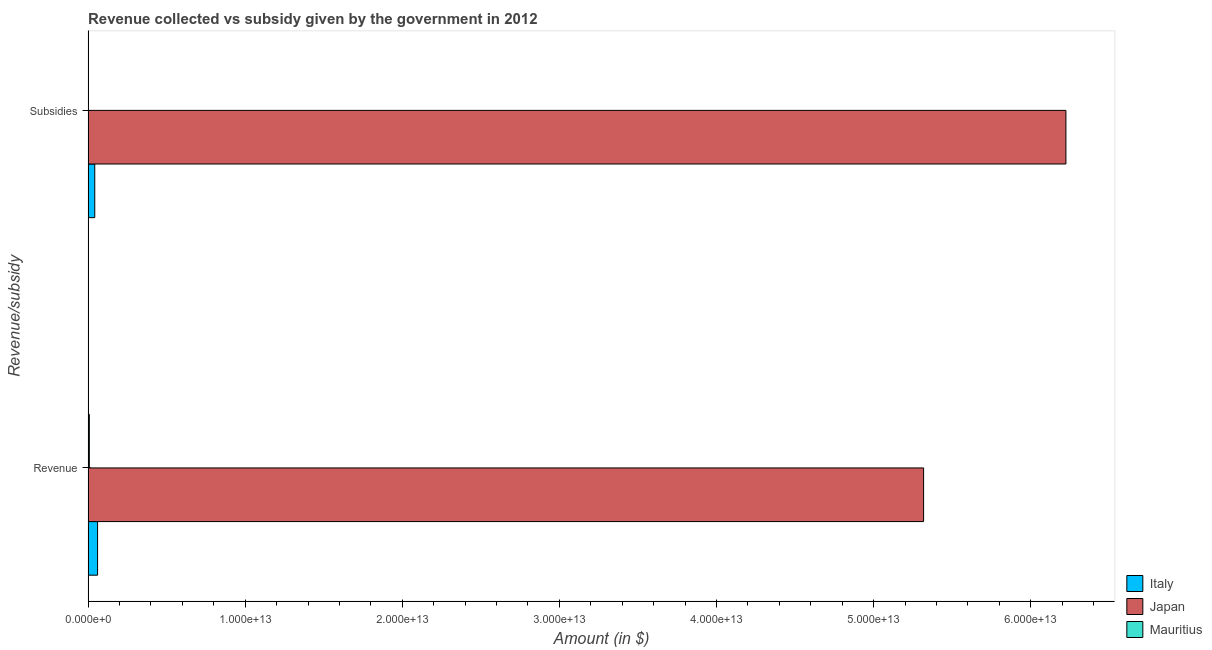How many groups of bars are there?
Give a very brief answer. 2. Are the number of bars per tick equal to the number of legend labels?
Offer a very short reply. Yes. How many bars are there on the 1st tick from the top?
Provide a short and direct response. 3. How many bars are there on the 1st tick from the bottom?
Offer a terse response. 3. What is the label of the 2nd group of bars from the top?
Offer a terse response. Revenue. What is the amount of subsidies given in Japan?
Your answer should be very brief. 6.22e+13. Across all countries, what is the maximum amount of revenue collected?
Provide a short and direct response. 5.32e+13. Across all countries, what is the minimum amount of revenue collected?
Your answer should be very brief. 7.91e+1. In which country was the amount of subsidies given maximum?
Keep it short and to the point. Japan. In which country was the amount of revenue collected minimum?
Give a very brief answer. Mauritius. What is the total amount of subsidies given in the graph?
Your answer should be compact. 6.27e+13. What is the difference between the amount of revenue collected in Mauritius and that in Japan?
Your answer should be very brief. -5.31e+13. What is the difference between the amount of revenue collected in Italy and the amount of subsidies given in Mauritius?
Provide a succinct answer. 5.79e+11. What is the average amount of revenue collected per country?
Make the answer very short. 1.80e+13. What is the difference between the amount of revenue collected and amount of subsidies given in Italy?
Your answer should be very brief. 1.78e+11. What is the ratio of the amount of subsidies given in Mauritius to that in Japan?
Your answer should be compact. 0. Is the amount of revenue collected in Italy less than that in Mauritius?
Your answer should be very brief. No. In how many countries, is the amount of revenue collected greater than the average amount of revenue collected taken over all countries?
Offer a terse response. 1. What does the 1st bar from the top in Subsidies represents?
Provide a succinct answer. Mauritius. What does the 1st bar from the bottom in Revenue represents?
Offer a very short reply. Italy. How many bars are there?
Ensure brevity in your answer.  6. Are all the bars in the graph horizontal?
Keep it short and to the point. Yes. How many countries are there in the graph?
Your answer should be compact. 3. What is the difference between two consecutive major ticks on the X-axis?
Offer a very short reply. 1.00e+13. Are the values on the major ticks of X-axis written in scientific E-notation?
Your answer should be very brief. Yes. Does the graph contain any zero values?
Give a very brief answer. No. Does the graph contain grids?
Offer a terse response. No. Where does the legend appear in the graph?
Your response must be concise. Bottom right. How are the legend labels stacked?
Ensure brevity in your answer.  Vertical. What is the title of the graph?
Offer a terse response. Revenue collected vs subsidy given by the government in 2012. What is the label or title of the X-axis?
Your answer should be very brief. Amount (in $). What is the label or title of the Y-axis?
Your answer should be very brief. Revenue/subsidy. What is the Amount (in $) in Italy in Revenue?
Give a very brief answer. 6.04e+11. What is the Amount (in $) in Japan in Revenue?
Your response must be concise. 5.32e+13. What is the Amount (in $) of Mauritius in Revenue?
Keep it short and to the point. 7.91e+1. What is the Amount (in $) of Italy in Subsidies?
Give a very brief answer. 4.25e+11. What is the Amount (in $) in Japan in Subsidies?
Make the answer very short. 6.22e+13. What is the Amount (in $) of Mauritius in Subsidies?
Offer a very short reply. 2.41e+1. Across all Revenue/subsidy, what is the maximum Amount (in $) in Italy?
Offer a terse response. 6.04e+11. Across all Revenue/subsidy, what is the maximum Amount (in $) of Japan?
Your answer should be compact. 6.22e+13. Across all Revenue/subsidy, what is the maximum Amount (in $) in Mauritius?
Give a very brief answer. 7.91e+1. Across all Revenue/subsidy, what is the minimum Amount (in $) of Italy?
Your answer should be very brief. 4.25e+11. Across all Revenue/subsidy, what is the minimum Amount (in $) of Japan?
Provide a succinct answer. 5.32e+13. Across all Revenue/subsidy, what is the minimum Amount (in $) of Mauritius?
Make the answer very short. 2.41e+1. What is the total Amount (in $) of Italy in the graph?
Your answer should be compact. 1.03e+12. What is the total Amount (in $) in Japan in the graph?
Make the answer very short. 1.15e+14. What is the total Amount (in $) in Mauritius in the graph?
Make the answer very short. 1.03e+11. What is the difference between the Amount (in $) in Italy in Revenue and that in Subsidies?
Make the answer very short. 1.78e+11. What is the difference between the Amount (in $) of Japan in Revenue and that in Subsidies?
Provide a succinct answer. -9.06e+12. What is the difference between the Amount (in $) in Mauritius in Revenue and that in Subsidies?
Provide a succinct answer. 5.50e+1. What is the difference between the Amount (in $) of Italy in Revenue and the Amount (in $) of Japan in Subsidies?
Ensure brevity in your answer.  -6.16e+13. What is the difference between the Amount (in $) in Italy in Revenue and the Amount (in $) in Mauritius in Subsidies?
Offer a very short reply. 5.79e+11. What is the difference between the Amount (in $) in Japan in Revenue and the Amount (in $) in Mauritius in Subsidies?
Provide a succinct answer. 5.32e+13. What is the average Amount (in $) in Italy per Revenue/subsidy?
Your answer should be compact. 5.14e+11. What is the average Amount (in $) of Japan per Revenue/subsidy?
Your response must be concise. 5.77e+13. What is the average Amount (in $) of Mauritius per Revenue/subsidy?
Keep it short and to the point. 5.16e+1. What is the difference between the Amount (in $) of Italy and Amount (in $) of Japan in Revenue?
Keep it short and to the point. -5.26e+13. What is the difference between the Amount (in $) of Italy and Amount (in $) of Mauritius in Revenue?
Offer a very short reply. 5.24e+11. What is the difference between the Amount (in $) in Japan and Amount (in $) in Mauritius in Revenue?
Offer a terse response. 5.31e+13. What is the difference between the Amount (in $) of Italy and Amount (in $) of Japan in Subsidies?
Keep it short and to the point. -6.18e+13. What is the difference between the Amount (in $) in Italy and Amount (in $) in Mauritius in Subsidies?
Ensure brevity in your answer.  4.01e+11. What is the difference between the Amount (in $) in Japan and Amount (in $) in Mauritius in Subsidies?
Keep it short and to the point. 6.22e+13. What is the ratio of the Amount (in $) of Italy in Revenue to that in Subsidies?
Provide a short and direct response. 1.42. What is the ratio of the Amount (in $) of Japan in Revenue to that in Subsidies?
Provide a short and direct response. 0.85. What is the ratio of the Amount (in $) of Mauritius in Revenue to that in Subsidies?
Offer a very short reply. 3.28. What is the difference between the highest and the second highest Amount (in $) of Italy?
Your answer should be very brief. 1.78e+11. What is the difference between the highest and the second highest Amount (in $) of Japan?
Ensure brevity in your answer.  9.06e+12. What is the difference between the highest and the second highest Amount (in $) in Mauritius?
Your answer should be very brief. 5.50e+1. What is the difference between the highest and the lowest Amount (in $) of Italy?
Offer a very short reply. 1.78e+11. What is the difference between the highest and the lowest Amount (in $) in Japan?
Keep it short and to the point. 9.06e+12. What is the difference between the highest and the lowest Amount (in $) of Mauritius?
Your response must be concise. 5.50e+1. 